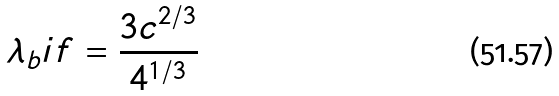<formula> <loc_0><loc_0><loc_500><loc_500>\lambda _ { b } i f = \frac { 3 c ^ { 2 / 3 } } { 4 ^ { 1 / 3 } }</formula> 